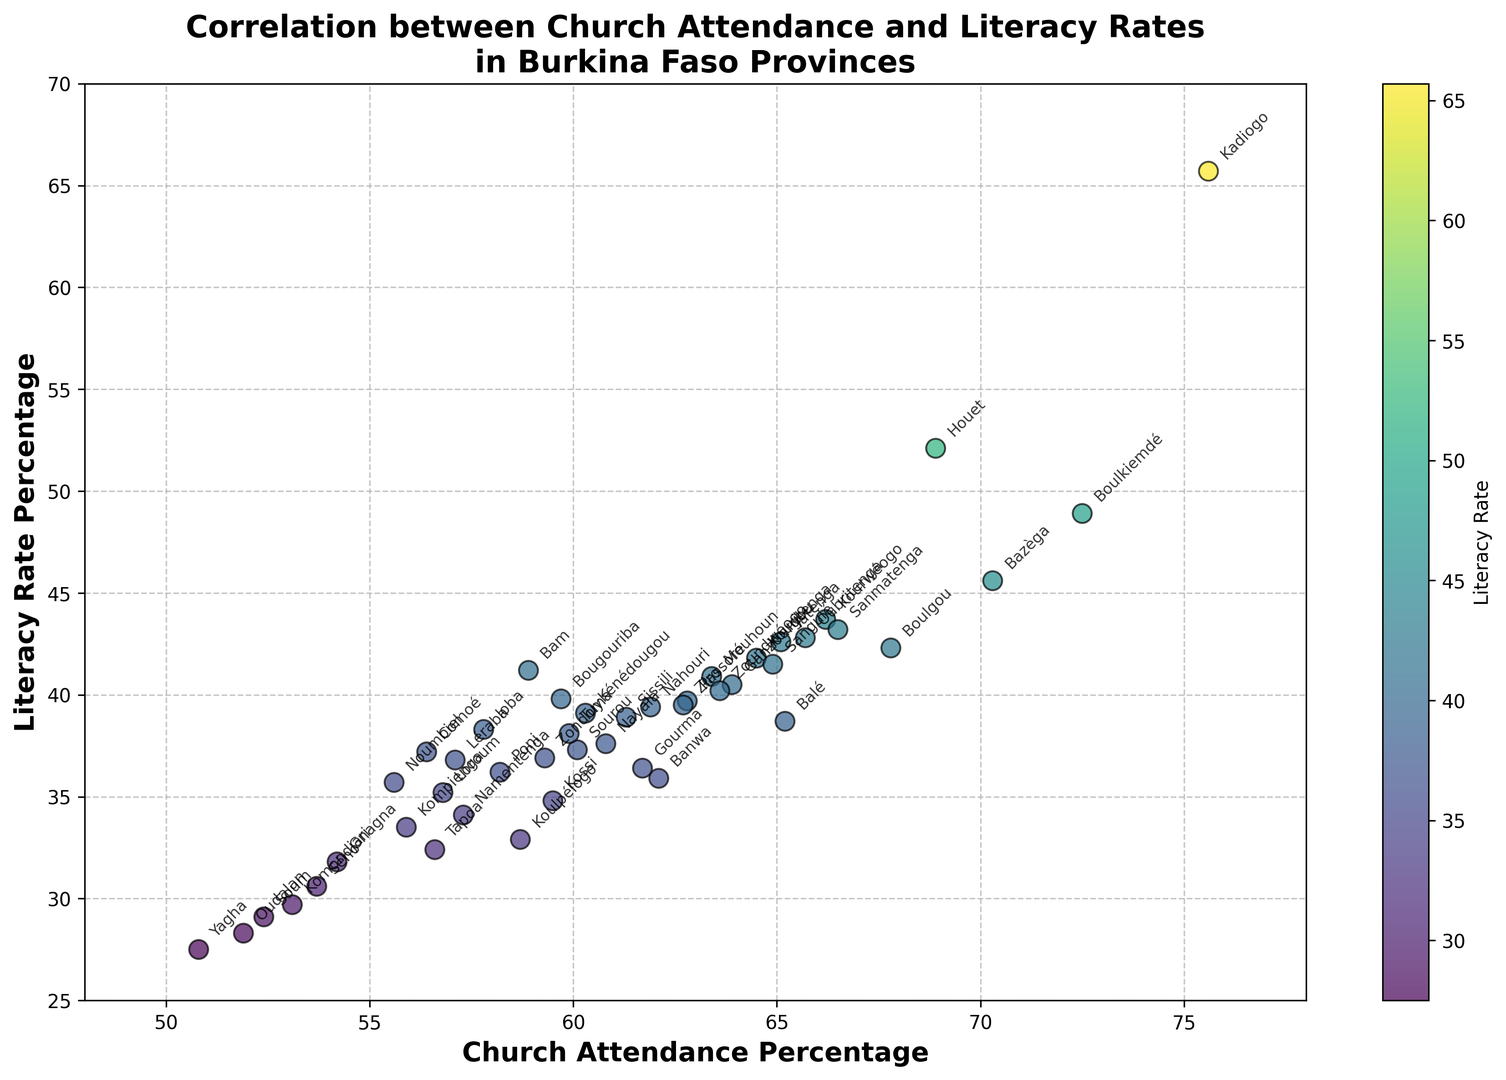Which province has the highest literacy rate? The province with the highest literacy rate is identified by finding the data point closest to the topmost part of the vertical axis labeled 'Literacy Rate Percentage'. This data point corresponds to Kadiogo.
Answer: Kadiogo Which province has the lowest church attendance? The province with the lowest church attendance is found by identifying the data point closest to the leftmost part of the horizontal axis labeled 'Church Attendance Percentage'. This data point corresponds to Yagha.
Answer: Yagha Is there a visible correlation between church attendance percentage and literacy rate percentage? To determine if there is a correlation, observe the general trend of the scatter points. If they form an upward or downward sloping line, that indicates correlation. Here, the points show an upward trend indicating that higher church attendance is generally associated with higher literacy rates.
Answer: Yes, positive correlation Which provinces have literacy rates greater than 40% but church attendance less than 60%? To answer this, look for data points above the 40% line on the y-axis and to the left of the 60% line on the x-axis. The provinces fitting these criteria are Bam and Bougouriba.
Answer: Bam, Bougouriba What is the average literacy rate for provinces with church attendance percentages above 65%? To find this, first identify the provinces with church attendance above 65% (Balé, Bazèga, Boulgou, Boulkiemdé, Kadiogo, Kouritenga, Kourwéogo, Oubritenga, Sanmatenga, Yatenga). Then calculate the average of their literacy rates ((38.7 + 45.6 + 42.3 + 48.9 + 65.7 + 41.8 + 43.7 + 42.8 + 43.2 + 42.6) / 10).
Answer: 45.53% Which province has a lower literacy rate, Sourou or Léraba? To determine this, compare the y-values corresponding to Sourou and Léraba on the scatter plot. Sourou has a literacy rate of 37.3%, while Léraba has a literacy rate of 36.8%. Thus, Léraba has a lower literacy rate.
Answer: Léraba Which province has the widest disparity between church attendance percentage and literacy rate percentage? Calculate the difference between church attendance and literacy rate for each province, then identify the maximum difference. Kadiogo has the highest disparity (75.6 - 65.7 = 9.9).
Answer: Kadiogo Do provinces with the highest literacy rates also have the highest church attendance rates? Look at the provinces located at the topmost part of the scatter plot and compare their church attendance percentages. Provinces like Kadiogo, Houet, Bazèga, and Boulkiemdé are some of the top ones and do exhibit high church attendance rates as well.
Answer: Yes What is the general color pattern indicating literacy rates in the scatter plot? Observing the scatter plot, the colors transition from darker to lighter shades (or vice versa) as literacy rates increase, with darker colors indicating lower literacy rates and lighter colors indicating higher literacy rates.
Answer: Dark to light Among the provinces with church attendance percentages between 55% and 65%, which has the highest literacy rate? Identify the data points where church attendance is between 55% and 65%, then identify the highest among their literacy rates. Boulgou has the highest literacy rate of 42.3% among this group.
Answer: Boulgou 